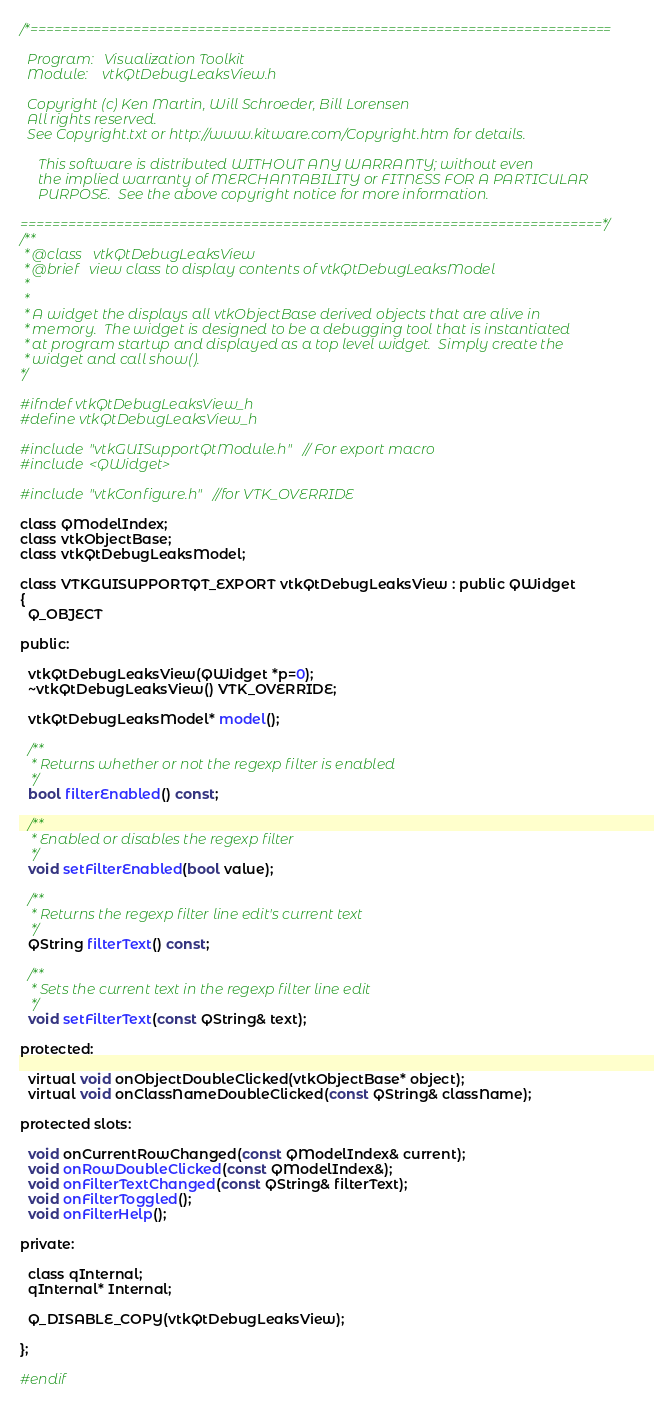<code> <loc_0><loc_0><loc_500><loc_500><_C_>/*=========================================================================

  Program:   Visualization Toolkit
  Module:    vtkQtDebugLeaksView.h

  Copyright (c) Ken Martin, Will Schroeder, Bill Lorensen
  All rights reserved.
  See Copyright.txt or http://www.kitware.com/Copyright.htm for details.

     This software is distributed WITHOUT ANY WARRANTY; without even
     the implied warranty of MERCHANTABILITY or FITNESS FOR A PARTICULAR
     PURPOSE.  See the above copyright notice for more information.

=========================================================================*/
/**
 * @class   vtkQtDebugLeaksView
 * @brief   view class to display contents of vtkQtDebugLeaksModel
 *
 *
 * A widget the displays all vtkObjectBase derived objects that are alive in
 * memory.  The widget is designed to be a debugging tool that is instantiated
 * at program startup and displayed as a top level widget.  Simply create the
 * widget and call show().
*/

#ifndef vtkQtDebugLeaksView_h
#define vtkQtDebugLeaksView_h

#include "vtkGUISupportQtModule.h" // For export macro
#include <QWidget>

#include "vtkConfigure.h" //for VTK_OVERRIDE

class QModelIndex;
class vtkObjectBase;
class vtkQtDebugLeaksModel;

class VTKGUISUPPORTQT_EXPORT vtkQtDebugLeaksView : public QWidget
{
  Q_OBJECT

public:

  vtkQtDebugLeaksView(QWidget *p=0);
  ~vtkQtDebugLeaksView() VTK_OVERRIDE;

  vtkQtDebugLeaksModel* model();

  /**
   * Returns whether or not the regexp filter is enabled
   */
  bool filterEnabled() const;

  /**
   * Enabled or disables the regexp filter
   */
  void setFilterEnabled(bool value);

  /**
   * Returns the regexp filter line edit's current text
   */
  QString filterText() const;

  /**
   * Sets the current text in the regexp filter line edit
   */
  void setFilterText(const QString& text);

protected:

  virtual void onObjectDoubleClicked(vtkObjectBase* object);
  virtual void onClassNameDoubleClicked(const QString& className);

protected slots:

  void onCurrentRowChanged(const QModelIndex& current);
  void onRowDoubleClicked(const QModelIndex&);
  void onFilterTextChanged(const QString& filterText);
  void onFilterToggled();
  void onFilterHelp();

private:

  class qInternal;
  qInternal* Internal;

  Q_DISABLE_COPY(vtkQtDebugLeaksView);

};

#endif
</code> 